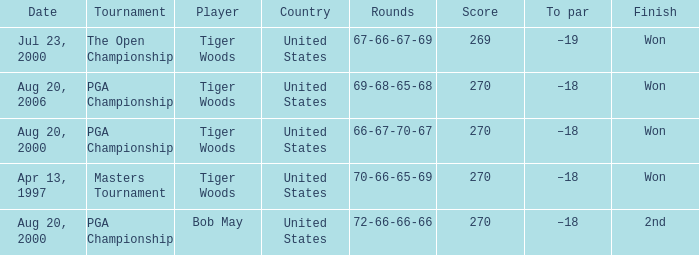What players finished 2nd? Bob May. 